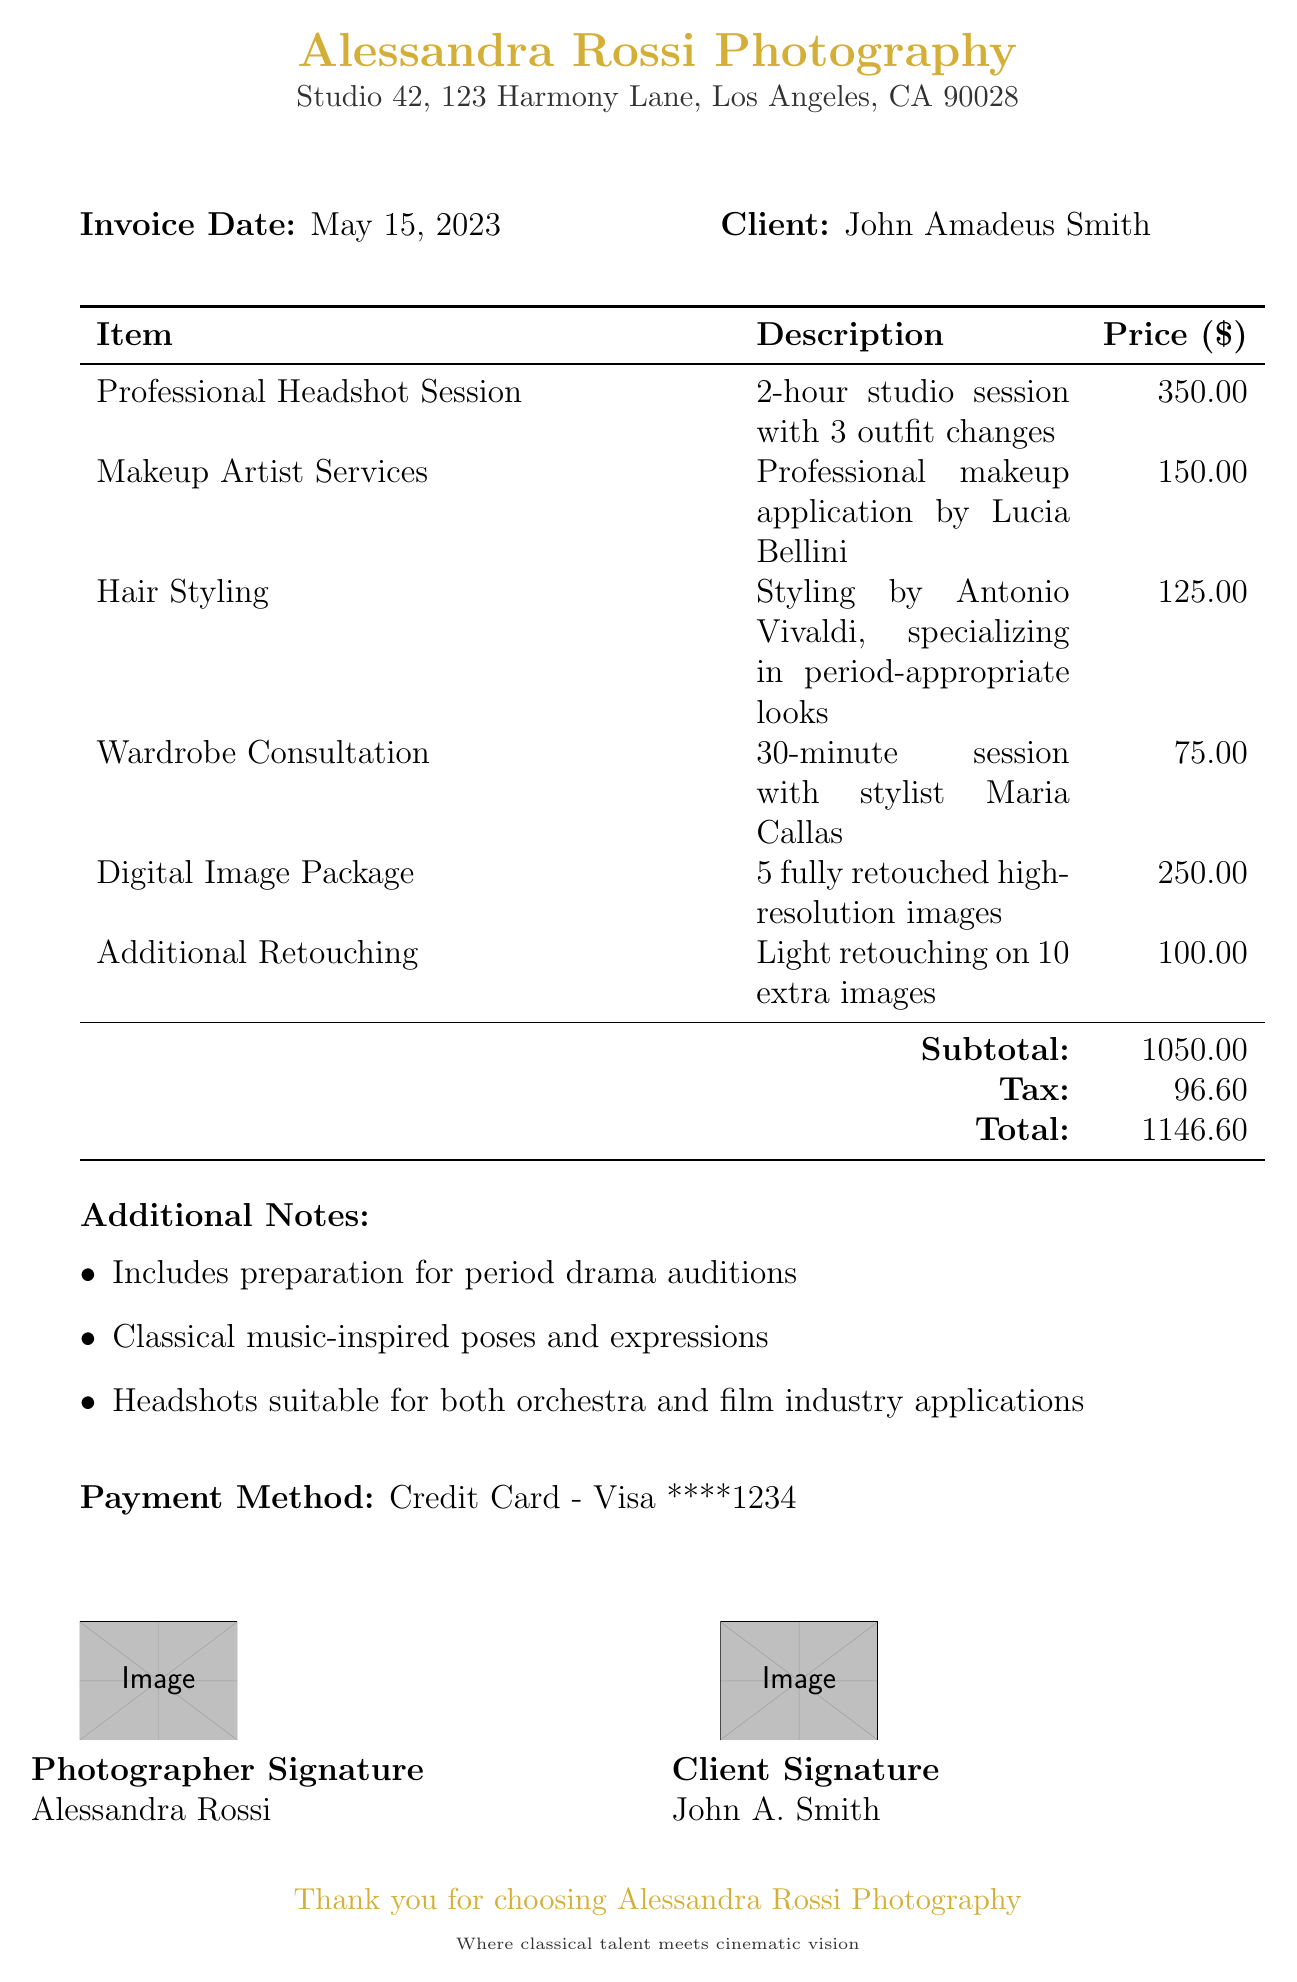what is the photographer's name? The photographer's name is displayed at the top of the invoice.
Answer: Alessandra Rossi Photography what is the client's name? The client's name is indicated in the document along with the invoice details.
Answer: John Amadeus Smith what date was the headshot session? The date of the professional headshot session is specified near the beginning of the document.
Answer: May 15, 2023 how much did the Digital Image Package cost? The cost of the Digital Image Package is detailed in the table of services.
Answer: 250.00 what is the subtotal amount? The subtotal is listed at the bottom of the service itemization in the document.
Answer: 1050.00 what services are included for makeup? The makeup service description is provided in the service list.
Answer: Professional makeup application by Lucia Bellini how many images are included in the Digital Image Package? The number of images included is stated clearly in the service description.
Answer: 5 what is the total amount due? The total amount due is calculated from the subtotal and tax in the invoice.
Answer: 1146.60 what type of payment method was used? The payment method is mentioned towards the end of the document.
Answer: Credit Card - Visa ****1234 